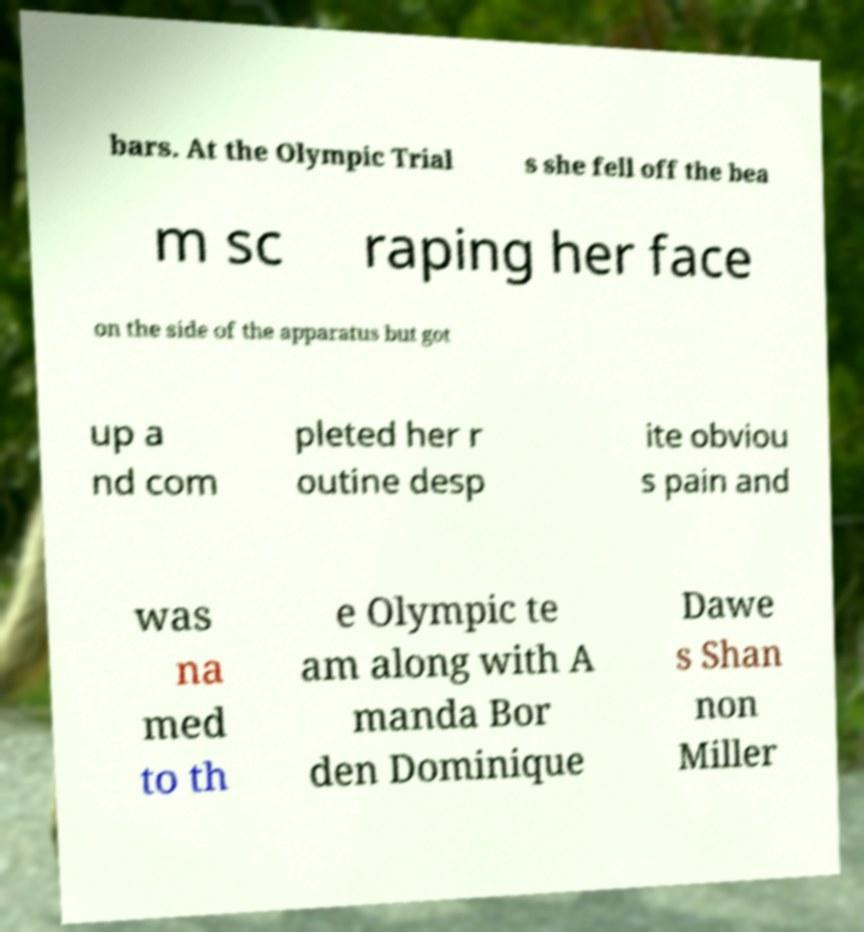There's text embedded in this image that I need extracted. Can you transcribe it verbatim? bars. At the Olympic Trial s she fell off the bea m sc raping her face on the side of the apparatus but got up a nd com pleted her r outine desp ite obviou s pain and was na med to th e Olympic te am along with A manda Bor den Dominique Dawe s Shan non Miller 